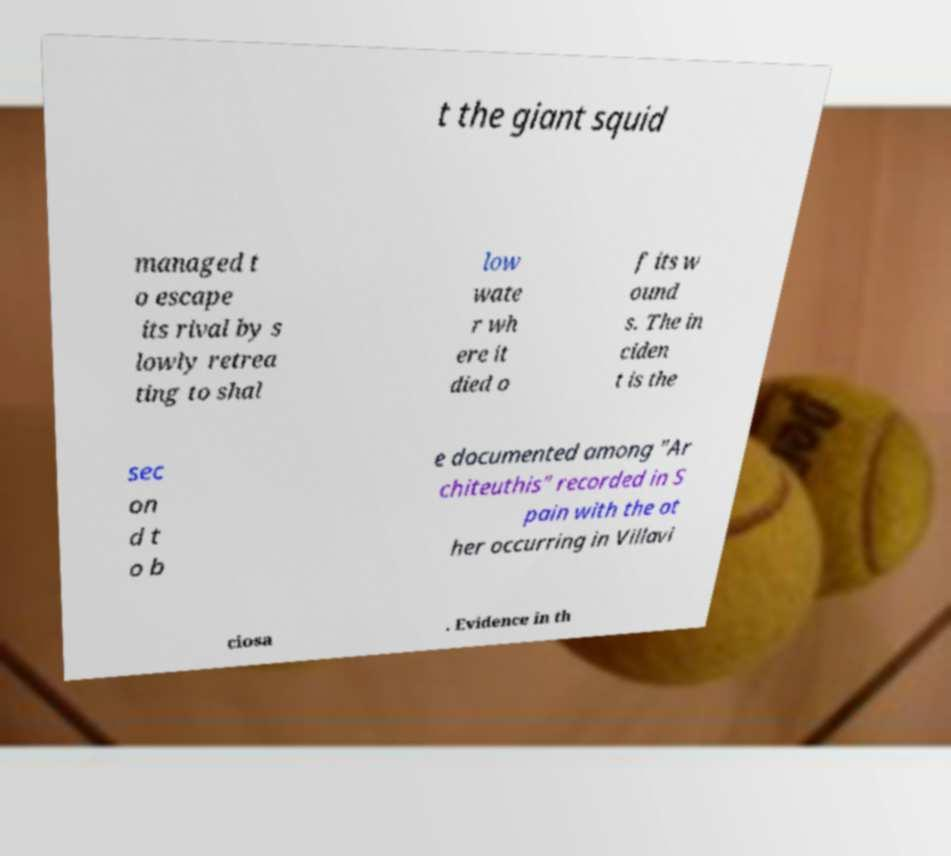What messages or text are displayed in this image? I need them in a readable, typed format. t the giant squid managed t o escape its rival by s lowly retrea ting to shal low wate r wh ere it died o f its w ound s. The in ciden t is the sec on d t o b e documented among "Ar chiteuthis" recorded in S pain with the ot her occurring in Villavi ciosa . Evidence in th 